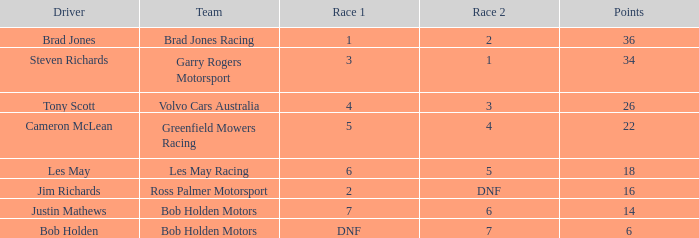In race 1, which driver from bob holden motors finished 7th and has not reached 36 points yet? Justin Mathews. 